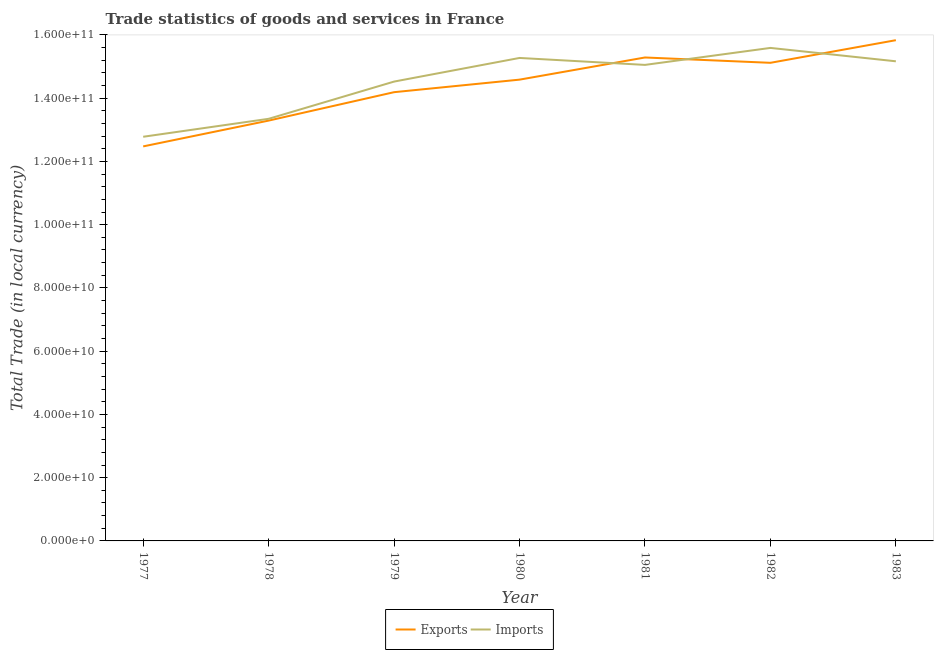How many different coloured lines are there?
Offer a terse response. 2. What is the export of goods and services in 1983?
Keep it short and to the point. 1.58e+11. Across all years, what is the maximum imports of goods and services?
Ensure brevity in your answer.  1.56e+11. Across all years, what is the minimum imports of goods and services?
Your answer should be compact. 1.28e+11. What is the total imports of goods and services in the graph?
Offer a terse response. 1.02e+12. What is the difference between the imports of goods and services in 1978 and that in 1983?
Your answer should be compact. -1.82e+1. What is the difference between the imports of goods and services in 1980 and the export of goods and services in 1977?
Offer a terse response. 2.80e+1. What is the average imports of goods and services per year?
Provide a succinct answer. 1.45e+11. In the year 1981, what is the difference between the export of goods and services and imports of goods and services?
Provide a succinct answer. 2.34e+09. In how many years, is the imports of goods and services greater than 4000000000 LCU?
Provide a short and direct response. 7. What is the ratio of the imports of goods and services in 1977 to that in 1983?
Your answer should be compact. 0.84. Is the difference between the imports of goods and services in 1981 and 1983 greater than the difference between the export of goods and services in 1981 and 1983?
Your answer should be very brief. Yes. What is the difference between the highest and the second highest imports of goods and services?
Keep it short and to the point. 3.17e+09. What is the difference between the highest and the lowest export of goods and services?
Keep it short and to the point. 3.36e+1. In how many years, is the imports of goods and services greater than the average imports of goods and services taken over all years?
Give a very brief answer. 4. Does the export of goods and services monotonically increase over the years?
Ensure brevity in your answer.  No. Is the imports of goods and services strictly greater than the export of goods and services over the years?
Ensure brevity in your answer.  No. How many lines are there?
Ensure brevity in your answer.  2. How many years are there in the graph?
Provide a succinct answer. 7. What is the difference between two consecutive major ticks on the Y-axis?
Offer a very short reply. 2.00e+1. Where does the legend appear in the graph?
Give a very brief answer. Bottom center. How are the legend labels stacked?
Give a very brief answer. Horizontal. What is the title of the graph?
Make the answer very short. Trade statistics of goods and services in France. What is the label or title of the Y-axis?
Offer a terse response. Total Trade (in local currency). What is the Total Trade (in local currency) in Exports in 1977?
Provide a short and direct response. 1.25e+11. What is the Total Trade (in local currency) in Imports in 1977?
Make the answer very short. 1.28e+11. What is the Total Trade (in local currency) in Exports in 1978?
Your answer should be very brief. 1.33e+11. What is the Total Trade (in local currency) in Imports in 1978?
Your response must be concise. 1.33e+11. What is the Total Trade (in local currency) in Exports in 1979?
Provide a short and direct response. 1.42e+11. What is the Total Trade (in local currency) of Imports in 1979?
Offer a very short reply. 1.45e+11. What is the Total Trade (in local currency) in Exports in 1980?
Provide a succinct answer. 1.46e+11. What is the Total Trade (in local currency) in Imports in 1980?
Ensure brevity in your answer.  1.53e+11. What is the Total Trade (in local currency) in Exports in 1981?
Keep it short and to the point. 1.53e+11. What is the Total Trade (in local currency) of Imports in 1981?
Offer a terse response. 1.51e+11. What is the Total Trade (in local currency) of Exports in 1982?
Your answer should be very brief. 1.51e+11. What is the Total Trade (in local currency) in Imports in 1982?
Offer a terse response. 1.56e+11. What is the Total Trade (in local currency) of Exports in 1983?
Ensure brevity in your answer.  1.58e+11. What is the Total Trade (in local currency) in Imports in 1983?
Provide a succinct answer. 1.52e+11. Across all years, what is the maximum Total Trade (in local currency) of Exports?
Make the answer very short. 1.58e+11. Across all years, what is the maximum Total Trade (in local currency) in Imports?
Offer a very short reply. 1.56e+11. Across all years, what is the minimum Total Trade (in local currency) in Exports?
Offer a terse response. 1.25e+11. Across all years, what is the minimum Total Trade (in local currency) of Imports?
Ensure brevity in your answer.  1.28e+11. What is the total Total Trade (in local currency) in Exports in the graph?
Your response must be concise. 1.01e+12. What is the total Total Trade (in local currency) in Imports in the graph?
Offer a very short reply. 1.02e+12. What is the difference between the Total Trade (in local currency) of Exports in 1977 and that in 1978?
Your answer should be compact. -8.16e+09. What is the difference between the Total Trade (in local currency) of Imports in 1977 and that in 1978?
Offer a terse response. -5.68e+09. What is the difference between the Total Trade (in local currency) in Exports in 1977 and that in 1979?
Offer a very short reply. -1.71e+1. What is the difference between the Total Trade (in local currency) in Imports in 1977 and that in 1979?
Your answer should be compact. -1.74e+1. What is the difference between the Total Trade (in local currency) of Exports in 1977 and that in 1980?
Offer a terse response. -2.11e+1. What is the difference between the Total Trade (in local currency) of Imports in 1977 and that in 1980?
Your answer should be compact. -2.49e+1. What is the difference between the Total Trade (in local currency) in Exports in 1977 and that in 1981?
Your answer should be compact. -2.81e+1. What is the difference between the Total Trade (in local currency) of Imports in 1977 and that in 1981?
Provide a succinct answer. -2.27e+1. What is the difference between the Total Trade (in local currency) of Exports in 1977 and that in 1982?
Keep it short and to the point. -2.64e+1. What is the difference between the Total Trade (in local currency) in Imports in 1977 and that in 1982?
Your answer should be very brief. -2.81e+1. What is the difference between the Total Trade (in local currency) in Exports in 1977 and that in 1983?
Offer a very short reply. -3.36e+1. What is the difference between the Total Trade (in local currency) of Imports in 1977 and that in 1983?
Your response must be concise. -2.39e+1. What is the difference between the Total Trade (in local currency) in Exports in 1978 and that in 1979?
Your response must be concise. -8.98e+09. What is the difference between the Total Trade (in local currency) of Imports in 1978 and that in 1979?
Make the answer very short. -1.18e+1. What is the difference between the Total Trade (in local currency) in Exports in 1978 and that in 1980?
Give a very brief answer. -1.30e+1. What is the difference between the Total Trade (in local currency) of Imports in 1978 and that in 1980?
Your answer should be compact. -1.92e+1. What is the difference between the Total Trade (in local currency) in Exports in 1978 and that in 1981?
Provide a succinct answer. -2.00e+1. What is the difference between the Total Trade (in local currency) of Imports in 1978 and that in 1981?
Give a very brief answer. -1.70e+1. What is the difference between the Total Trade (in local currency) in Exports in 1978 and that in 1982?
Offer a terse response. -1.83e+1. What is the difference between the Total Trade (in local currency) in Imports in 1978 and that in 1982?
Your response must be concise. -2.24e+1. What is the difference between the Total Trade (in local currency) in Exports in 1978 and that in 1983?
Give a very brief answer. -2.54e+1. What is the difference between the Total Trade (in local currency) in Imports in 1978 and that in 1983?
Make the answer very short. -1.82e+1. What is the difference between the Total Trade (in local currency) in Exports in 1979 and that in 1980?
Your response must be concise. -3.97e+09. What is the difference between the Total Trade (in local currency) of Imports in 1979 and that in 1980?
Ensure brevity in your answer.  -7.47e+09. What is the difference between the Total Trade (in local currency) in Exports in 1979 and that in 1981?
Your answer should be very brief. -1.10e+1. What is the difference between the Total Trade (in local currency) in Imports in 1979 and that in 1981?
Provide a short and direct response. -5.28e+09. What is the difference between the Total Trade (in local currency) in Exports in 1979 and that in 1982?
Ensure brevity in your answer.  -9.29e+09. What is the difference between the Total Trade (in local currency) of Imports in 1979 and that in 1982?
Provide a succinct answer. -1.06e+1. What is the difference between the Total Trade (in local currency) of Exports in 1979 and that in 1983?
Provide a succinct answer. -1.64e+1. What is the difference between the Total Trade (in local currency) in Imports in 1979 and that in 1983?
Your answer should be very brief. -6.41e+09. What is the difference between the Total Trade (in local currency) of Exports in 1980 and that in 1981?
Make the answer very short. -7.00e+09. What is the difference between the Total Trade (in local currency) of Imports in 1980 and that in 1981?
Provide a short and direct response. 2.20e+09. What is the difference between the Total Trade (in local currency) of Exports in 1980 and that in 1982?
Your answer should be very brief. -5.32e+09. What is the difference between the Total Trade (in local currency) of Imports in 1980 and that in 1982?
Your answer should be very brief. -3.17e+09. What is the difference between the Total Trade (in local currency) in Exports in 1980 and that in 1983?
Keep it short and to the point. -1.25e+1. What is the difference between the Total Trade (in local currency) of Imports in 1980 and that in 1983?
Offer a very short reply. 1.06e+09. What is the difference between the Total Trade (in local currency) in Exports in 1981 and that in 1982?
Make the answer very short. 1.68e+09. What is the difference between the Total Trade (in local currency) of Imports in 1981 and that in 1982?
Your response must be concise. -5.37e+09. What is the difference between the Total Trade (in local currency) in Exports in 1981 and that in 1983?
Ensure brevity in your answer.  -5.47e+09. What is the difference between the Total Trade (in local currency) in Imports in 1981 and that in 1983?
Make the answer very short. -1.14e+09. What is the difference between the Total Trade (in local currency) in Exports in 1982 and that in 1983?
Ensure brevity in your answer.  -7.16e+09. What is the difference between the Total Trade (in local currency) in Imports in 1982 and that in 1983?
Your answer should be very brief. 4.23e+09. What is the difference between the Total Trade (in local currency) of Exports in 1977 and the Total Trade (in local currency) of Imports in 1978?
Give a very brief answer. -8.72e+09. What is the difference between the Total Trade (in local currency) of Exports in 1977 and the Total Trade (in local currency) of Imports in 1979?
Your answer should be compact. -2.05e+1. What is the difference between the Total Trade (in local currency) of Exports in 1977 and the Total Trade (in local currency) of Imports in 1980?
Ensure brevity in your answer.  -2.80e+1. What is the difference between the Total Trade (in local currency) in Exports in 1977 and the Total Trade (in local currency) in Imports in 1981?
Keep it short and to the point. -2.58e+1. What is the difference between the Total Trade (in local currency) in Exports in 1977 and the Total Trade (in local currency) in Imports in 1982?
Make the answer very short. -3.11e+1. What is the difference between the Total Trade (in local currency) of Exports in 1977 and the Total Trade (in local currency) of Imports in 1983?
Keep it short and to the point. -2.69e+1. What is the difference between the Total Trade (in local currency) of Exports in 1978 and the Total Trade (in local currency) of Imports in 1979?
Make the answer very short. -1.23e+1. What is the difference between the Total Trade (in local currency) in Exports in 1978 and the Total Trade (in local currency) in Imports in 1980?
Ensure brevity in your answer.  -1.98e+1. What is the difference between the Total Trade (in local currency) in Exports in 1978 and the Total Trade (in local currency) in Imports in 1981?
Ensure brevity in your answer.  -1.76e+1. What is the difference between the Total Trade (in local currency) of Exports in 1978 and the Total Trade (in local currency) of Imports in 1982?
Your answer should be very brief. -2.30e+1. What is the difference between the Total Trade (in local currency) of Exports in 1978 and the Total Trade (in local currency) of Imports in 1983?
Your answer should be very brief. -1.87e+1. What is the difference between the Total Trade (in local currency) of Exports in 1979 and the Total Trade (in local currency) of Imports in 1980?
Make the answer very short. -1.08e+1. What is the difference between the Total Trade (in local currency) in Exports in 1979 and the Total Trade (in local currency) in Imports in 1981?
Make the answer very short. -8.63e+09. What is the difference between the Total Trade (in local currency) in Exports in 1979 and the Total Trade (in local currency) in Imports in 1982?
Your answer should be compact. -1.40e+1. What is the difference between the Total Trade (in local currency) in Exports in 1979 and the Total Trade (in local currency) in Imports in 1983?
Provide a succinct answer. -9.76e+09. What is the difference between the Total Trade (in local currency) in Exports in 1980 and the Total Trade (in local currency) in Imports in 1981?
Ensure brevity in your answer.  -4.66e+09. What is the difference between the Total Trade (in local currency) of Exports in 1980 and the Total Trade (in local currency) of Imports in 1982?
Offer a terse response. -1.00e+1. What is the difference between the Total Trade (in local currency) in Exports in 1980 and the Total Trade (in local currency) in Imports in 1983?
Your answer should be very brief. -5.80e+09. What is the difference between the Total Trade (in local currency) of Exports in 1981 and the Total Trade (in local currency) of Imports in 1982?
Provide a short and direct response. -3.03e+09. What is the difference between the Total Trade (in local currency) in Exports in 1981 and the Total Trade (in local currency) in Imports in 1983?
Offer a terse response. 1.21e+09. What is the difference between the Total Trade (in local currency) in Exports in 1982 and the Total Trade (in local currency) in Imports in 1983?
Make the answer very short. -4.79e+08. What is the average Total Trade (in local currency) of Exports per year?
Ensure brevity in your answer.  1.44e+11. What is the average Total Trade (in local currency) of Imports per year?
Keep it short and to the point. 1.45e+11. In the year 1977, what is the difference between the Total Trade (in local currency) in Exports and Total Trade (in local currency) in Imports?
Give a very brief answer. -3.05e+09. In the year 1978, what is the difference between the Total Trade (in local currency) in Exports and Total Trade (in local currency) in Imports?
Give a very brief answer. -5.63e+08. In the year 1979, what is the difference between the Total Trade (in local currency) of Exports and Total Trade (in local currency) of Imports?
Ensure brevity in your answer.  -3.35e+09. In the year 1980, what is the difference between the Total Trade (in local currency) of Exports and Total Trade (in local currency) of Imports?
Your answer should be compact. -6.86e+09. In the year 1981, what is the difference between the Total Trade (in local currency) of Exports and Total Trade (in local currency) of Imports?
Offer a very short reply. 2.34e+09. In the year 1982, what is the difference between the Total Trade (in local currency) in Exports and Total Trade (in local currency) in Imports?
Your response must be concise. -4.71e+09. In the year 1983, what is the difference between the Total Trade (in local currency) of Exports and Total Trade (in local currency) of Imports?
Your answer should be compact. 6.68e+09. What is the ratio of the Total Trade (in local currency) in Exports in 1977 to that in 1978?
Your response must be concise. 0.94. What is the ratio of the Total Trade (in local currency) in Imports in 1977 to that in 1978?
Your answer should be compact. 0.96. What is the ratio of the Total Trade (in local currency) of Exports in 1977 to that in 1979?
Keep it short and to the point. 0.88. What is the ratio of the Total Trade (in local currency) of Imports in 1977 to that in 1979?
Your response must be concise. 0.88. What is the ratio of the Total Trade (in local currency) in Exports in 1977 to that in 1980?
Your response must be concise. 0.86. What is the ratio of the Total Trade (in local currency) in Imports in 1977 to that in 1980?
Your answer should be compact. 0.84. What is the ratio of the Total Trade (in local currency) of Exports in 1977 to that in 1981?
Offer a terse response. 0.82. What is the ratio of the Total Trade (in local currency) of Imports in 1977 to that in 1981?
Provide a short and direct response. 0.85. What is the ratio of the Total Trade (in local currency) in Exports in 1977 to that in 1982?
Provide a succinct answer. 0.83. What is the ratio of the Total Trade (in local currency) of Imports in 1977 to that in 1982?
Provide a short and direct response. 0.82. What is the ratio of the Total Trade (in local currency) of Exports in 1977 to that in 1983?
Provide a short and direct response. 0.79. What is the ratio of the Total Trade (in local currency) of Imports in 1977 to that in 1983?
Your response must be concise. 0.84. What is the ratio of the Total Trade (in local currency) of Exports in 1978 to that in 1979?
Keep it short and to the point. 0.94. What is the ratio of the Total Trade (in local currency) in Imports in 1978 to that in 1979?
Give a very brief answer. 0.92. What is the ratio of the Total Trade (in local currency) in Exports in 1978 to that in 1980?
Keep it short and to the point. 0.91. What is the ratio of the Total Trade (in local currency) in Imports in 1978 to that in 1980?
Your response must be concise. 0.87. What is the ratio of the Total Trade (in local currency) of Exports in 1978 to that in 1981?
Offer a very short reply. 0.87. What is the ratio of the Total Trade (in local currency) of Imports in 1978 to that in 1981?
Your answer should be very brief. 0.89. What is the ratio of the Total Trade (in local currency) of Exports in 1978 to that in 1982?
Your response must be concise. 0.88. What is the ratio of the Total Trade (in local currency) in Imports in 1978 to that in 1982?
Offer a terse response. 0.86. What is the ratio of the Total Trade (in local currency) of Exports in 1978 to that in 1983?
Ensure brevity in your answer.  0.84. What is the ratio of the Total Trade (in local currency) in Imports in 1978 to that in 1983?
Make the answer very short. 0.88. What is the ratio of the Total Trade (in local currency) in Exports in 1979 to that in 1980?
Make the answer very short. 0.97. What is the ratio of the Total Trade (in local currency) of Imports in 1979 to that in 1980?
Your answer should be very brief. 0.95. What is the ratio of the Total Trade (in local currency) in Exports in 1979 to that in 1981?
Keep it short and to the point. 0.93. What is the ratio of the Total Trade (in local currency) in Imports in 1979 to that in 1981?
Your answer should be very brief. 0.96. What is the ratio of the Total Trade (in local currency) in Exports in 1979 to that in 1982?
Offer a terse response. 0.94. What is the ratio of the Total Trade (in local currency) of Imports in 1979 to that in 1982?
Provide a short and direct response. 0.93. What is the ratio of the Total Trade (in local currency) in Exports in 1979 to that in 1983?
Your answer should be compact. 0.9. What is the ratio of the Total Trade (in local currency) in Imports in 1979 to that in 1983?
Offer a terse response. 0.96. What is the ratio of the Total Trade (in local currency) in Exports in 1980 to that in 1981?
Your answer should be compact. 0.95. What is the ratio of the Total Trade (in local currency) of Imports in 1980 to that in 1981?
Provide a succinct answer. 1.01. What is the ratio of the Total Trade (in local currency) in Exports in 1980 to that in 1982?
Provide a succinct answer. 0.96. What is the ratio of the Total Trade (in local currency) of Imports in 1980 to that in 1982?
Give a very brief answer. 0.98. What is the ratio of the Total Trade (in local currency) of Exports in 1980 to that in 1983?
Ensure brevity in your answer.  0.92. What is the ratio of the Total Trade (in local currency) of Imports in 1980 to that in 1983?
Keep it short and to the point. 1.01. What is the ratio of the Total Trade (in local currency) in Exports in 1981 to that in 1982?
Your answer should be compact. 1.01. What is the ratio of the Total Trade (in local currency) in Imports in 1981 to that in 1982?
Keep it short and to the point. 0.97. What is the ratio of the Total Trade (in local currency) of Exports in 1981 to that in 1983?
Give a very brief answer. 0.97. What is the ratio of the Total Trade (in local currency) in Imports in 1981 to that in 1983?
Provide a short and direct response. 0.99. What is the ratio of the Total Trade (in local currency) of Exports in 1982 to that in 1983?
Make the answer very short. 0.95. What is the ratio of the Total Trade (in local currency) of Imports in 1982 to that in 1983?
Provide a succinct answer. 1.03. What is the difference between the highest and the second highest Total Trade (in local currency) in Exports?
Keep it short and to the point. 5.47e+09. What is the difference between the highest and the second highest Total Trade (in local currency) in Imports?
Give a very brief answer. 3.17e+09. What is the difference between the highest and the lowest Total Trade (in local currency) of Exports?
Offer a very short reply. 3.36e+1. What is the difference between the highest and the lowest Total Trade (in local currency) of Imports?
Your answer should be very brief. 2.81e+1. 